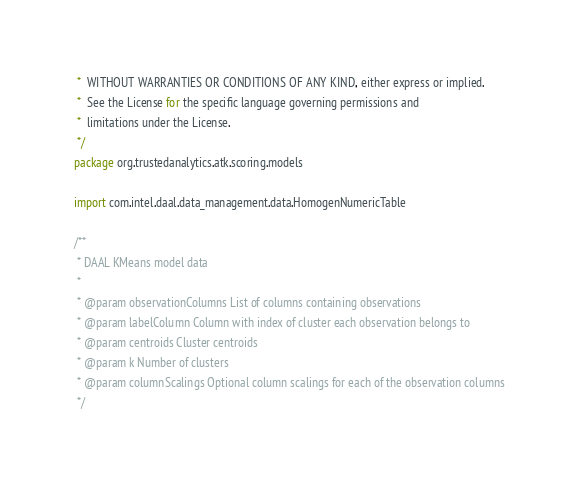<code> <loc_0><loc_0><loc_500><loc_500><_Scala_> *  WITHOUT WARRANTIES OR CONDITIONS OF ANY KIND, either express or implied.
 *  See the License for the specific language governing permissions and
 *  limitations under the License.
 */
package org.trustedanalytics.atk.scoring.models

import com.intel.daal.data_management.data.HomogenNumericTable

/**
 * DAAL KMeans model data
 *
 * @param observationColumns List of columns containing observations
 * @param labelColumn Column with index of cluster each observation belongs to
 * @param centroids Cluster centroids
 * @param k Number of clusters
 * @param columnScalings Optional column scalings for each of the observation columns
 */</code> 